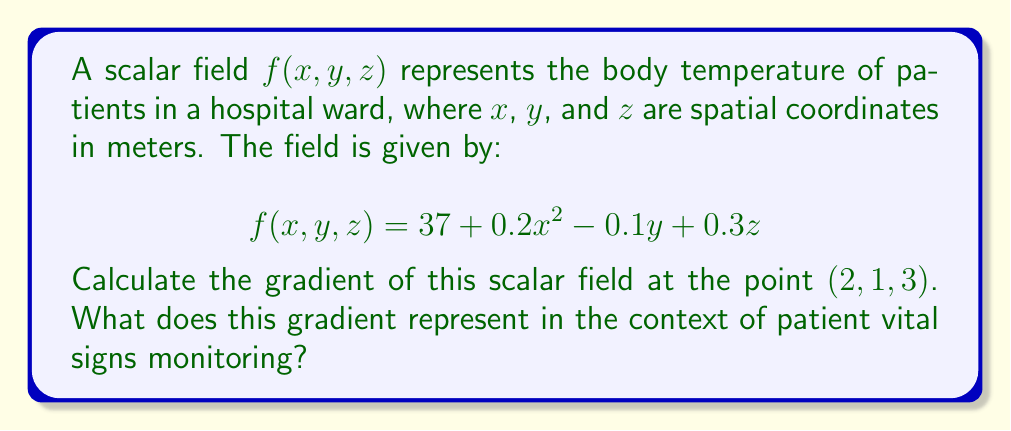Help me with this question. To solve this problem, we'll follow these steps:

1) The gradient of a scalar field $f(x,y,z)$ is defined as:

   $$\nabla f = \left(\frac{\partial f}{\partial x}, \frac{\partial f}{\partial y}, \frac{\partial f}{\partial z}\right)$$

2) Let's calculate each partial derivative:

   $\frac{\partial f}{\partial x} = 0.4x$
   $\frac{\partial f}{\partial y} = -0.1$
   $\frac{\partial f}{\partial z} = 0.3$

3) Now, we can write the gradient as a function:

   $$\nabla f(x,y,z) = (0.4x, -0.1, 0.3)$$

4) To find the gradient at the point $(2, 1, 3)$, we simply substitute these values:

   $$\nabla f(2, 1, 3) = (0.4(2), -0.1, 0.3) = (0.8, -0.1, 0.3)$$

5) Interpretation: The gradient represents the direction and magnitude of the steepest increase in temperature. Each component indicates how quickly the temperature changes in that direction:
   - The x-component (0.8) shows temperature increases most rapidly in the positive x-direction.
   - The y-component (-0.1) indicates a slight decrease in temperature in the positive y-direction.
   - The z-component (0.3) shows a moderate increase in temperature in the positive z-direction.

This information is crucial for nurses monitoring patient vital signs, as it helps identify areas of the ward where temperature changes most rapidly, potentially indicating areas that need attention in terms of climate control or patient care.
Answer: $\nabla f(2, 1, 3) = (0.8, -0.1, 0.3)$ 